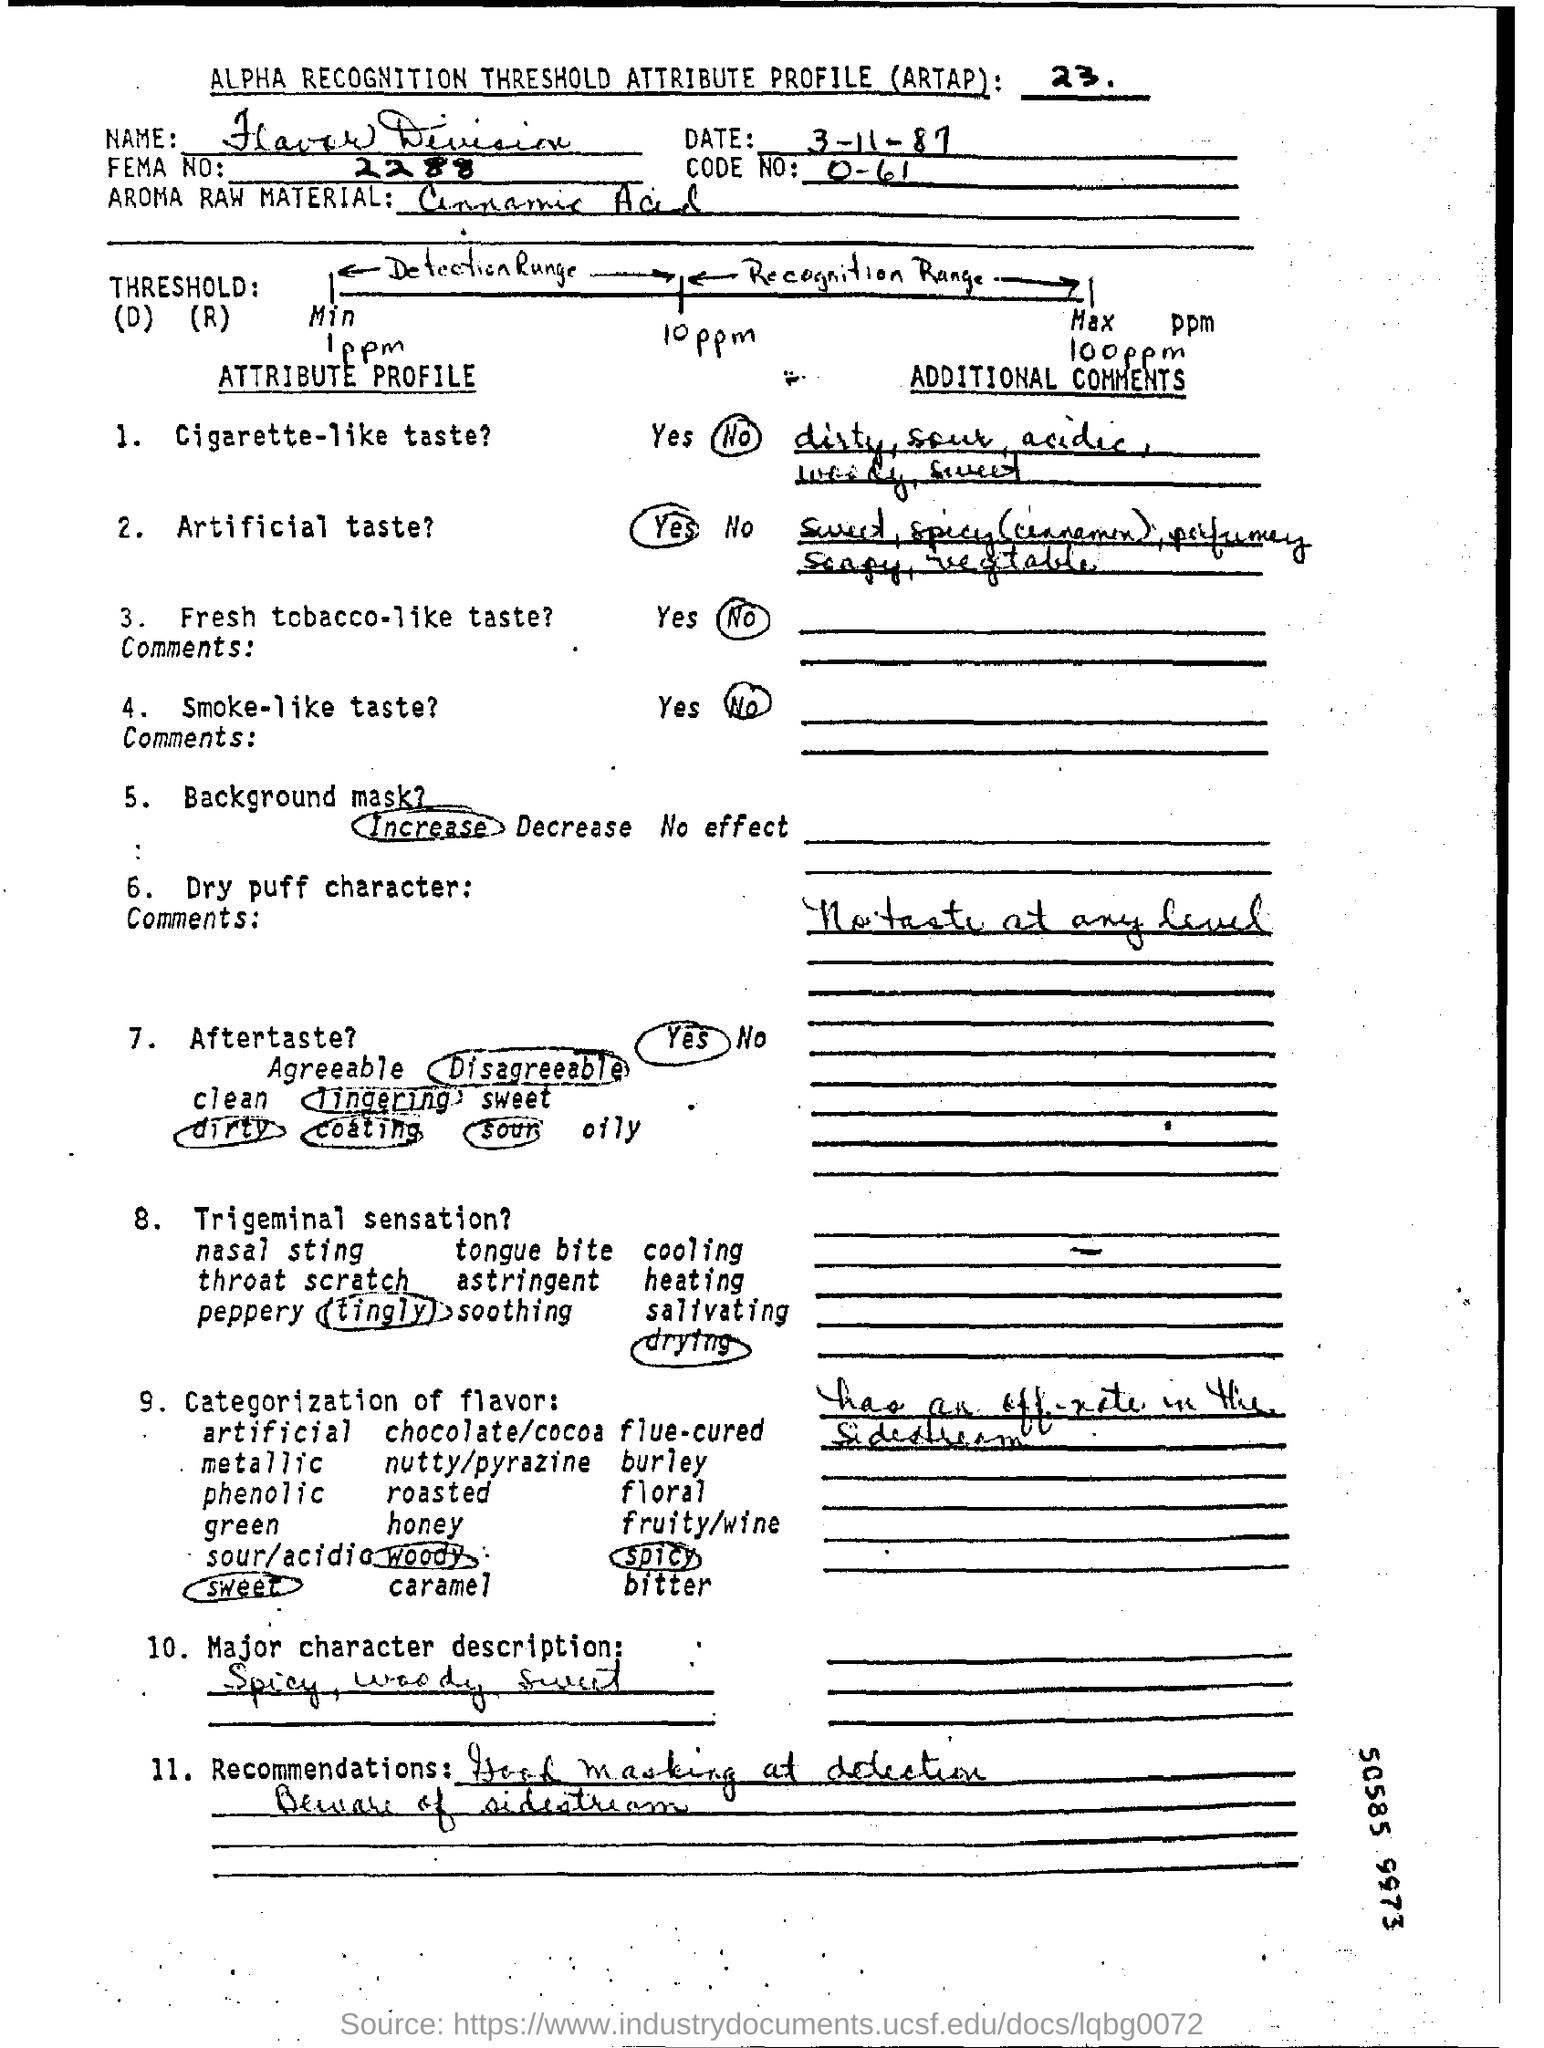What is the date mentioned in the top of the document ?
Provide a succinct answer. 3-11-87. What is the Code Number ?
Keep it short and to the point. 0-61. What is the FEMA Number ?
Provide a short and direct response. 2288. 